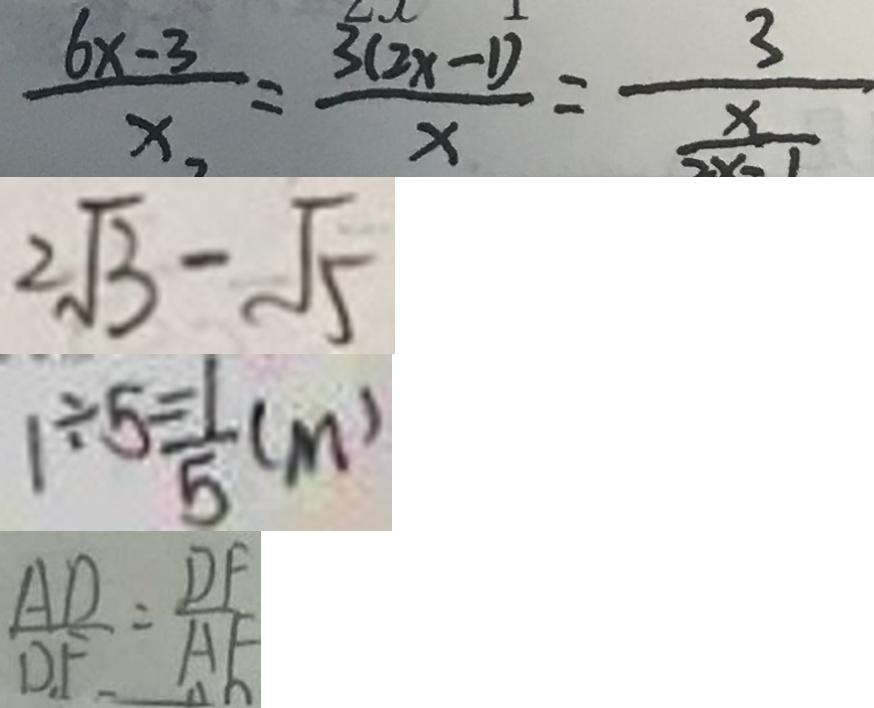Convert formula to latex. <formula><loc_0><loc_0><loc_500><loc_500>\frac { 6 x - 3 } { x } = \frac { 3 ( 2 x - 1 ) } { x } = \frac { 3 } { \frac { x } { 2 x - 1 } } 
 2 \sqrt { 3 } - \sqrt { 5 } 
 1 \div 5 = \frac { 1 } { 5 } ( m ) 
 \frac { A D } { D F } = \frac { D F } { A F }</formula> 